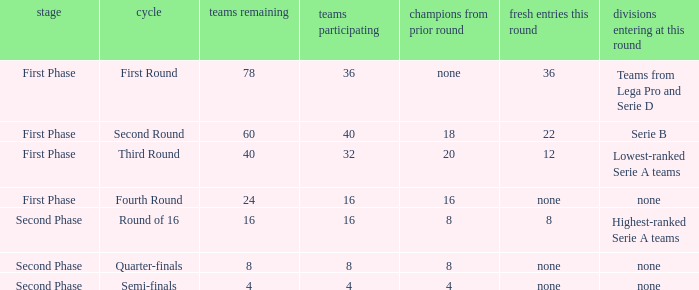The new entries this round was shown to be 12, in which phase would you find this? First Phase. 